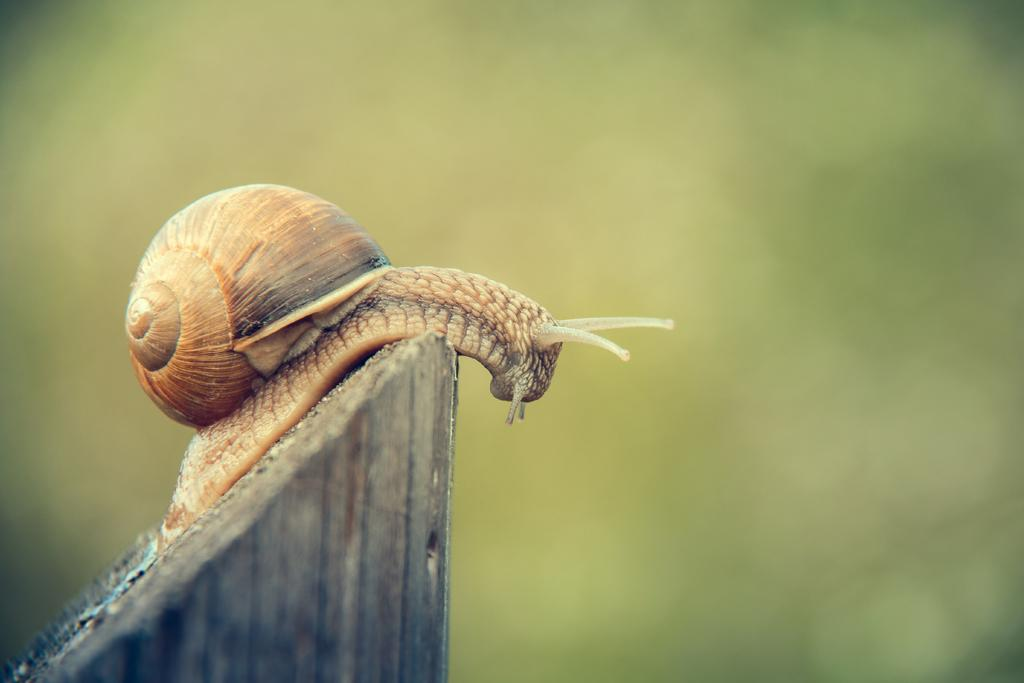What is the main subject of the image? There is a snail in the image. What is the snail resting on? The snail is on a wooden object. Can you describe the background of the image? The background of the image is blurred. What type of attraction can be seen in the background of the image? There is no attraction visible in the image; the background is blurred. How many crows are present in the image? There are no crows present in the image; it features a snail on a wooden object with a blurred background. 